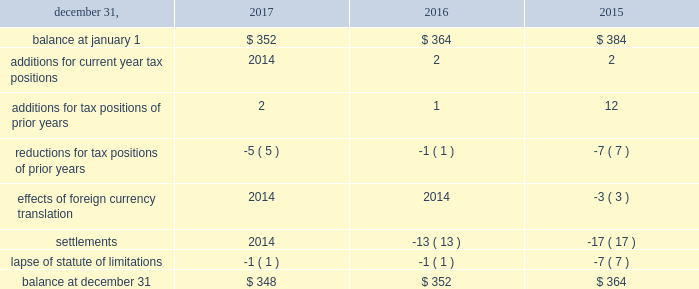The aes corporation notes to consolidated financial statements 2014 ( continued ) december 31 , 2017 , 2016 , and 2015 the total amount of unrecognized tax benefits anticipated to result in a net decrease to unrecognized tax benefits within 12 months of december 31 , 2017 is estimated to be between $ 5 million and $ 15 million , primarily relating to statute of limitation lapses and tax exam settlements .
The following is a reconciliation of the beginning and ending amounts of unrecognized tax benefits for the periods indicated ( in millions ) : .
The company and certain of its subsidiaries are currently under examination by the relevant taxing authorities for various tax years .
The company regularly assesses the potential outcome of these examinations in each of the taxing jurisdictions when determining the adequacy of the amount of unrecognized tax benefit recorded .
While it is often difficult to predict the final outcome or the timing of resolution of any particular uncertain tax position , we believe we have appropriately accrued for our uncertain tax benefits .
However , audit outcomes and the timing of audit settlements and future events that would impact our previously recorded unrecognized tax benefits and the range of anticipated increases or decreases in unrecognized tax benefits are subject to significant uncertainty .
It is possible that the ultimate outcome of current or future examinations may exceed our provision for current unrecognized tax benefits in amounts that could be material , but cannot be estimated as of december 31 , 2017 .
Our effective tax rate and net income in any given future period could therefore be materially impacted .
21 .
Discontinued operations due to a portfolio evaluation in the first half of 2016 , management decided to pursue a strategic shift of its distribution companies in brazil , sul and eletropaulo , to reduce the company's exposure to the brazilian distribution market .
Eletropaulo 2014 in november 2017 , eletropaulo converted its preferred shares into ordinary shares and transitioned the listing of those shares into the novo mercado , which is a listing segment of the brazilian stock exchange with the highest standards of corporate governance .
Upon conversion of the preferred shares into ordinary shares , aes no longer controlled eletropaulo , but maintained significant influence over the business .
As a result , the company deconsolidated eletropaulo .
After deconsolidation , the company's 17% ( 17 % ) ownership interest is reflected as an equity method investment .
The company recorded an after-tax loss on deconsolidation of $ 611 million , which primarily consisted of $ 455 million related to cumulative translation losses and $ 243 million related to pension losses reclassified from aocl .
In december 2017 , all the remaining criteria were met for eletropaulo to qualify as a discontinued operation .
Therefore , its results of operations and financial position were reported as such in the consolidated financial statements for all periods presented .
Eletropaulo's pre-tax loss attributable to aes , including the loss on deconsolidation , for the years ended december 31 , 2017 and 2016 was $ 633 million and $ 192 million , respectively .
Eletropaulo's pre-tax income attributable to aes for the year ended december 31 , 2015 was $ 73 million .
Prior to its classification as discontinued operations , eletropaulo was reported in the brazil sbu reportable segment .
Sul 2014 the company executed an agreement for the sale of sul , a wholly-owned subsidiary , in june 2016 .
The results of operations and financial position of sul are reported as discontinued operations in the consolidated financial statements for all periods presented .
Upon meeting the held-for-sale criteria , the company recognized an after-tax loss of $ 382 million comprised of a pre-tax impairment charge of $ 783 million , offset by a tax benefit of $ 266 million related to the impairment of the sul long lived assets and a tax benefit of $ 135 million for deferred taxes related to the investment in sul .
Prior to the impairment charge , the carrying value of the sul asset group of $ 1.6 billion was greater than its approximate fair value less costs to sell .
However , the impairment charge was limited to the carrying value of the long lived assets of the sul disposal group .
On october 31 , 2016 , the company completed the sale of sul and received final proceeds less costs to sell of $ 484 million , excluding contingent consideration .
Upon disposal of sul , the company incurred an additional after-tax .
What would the ending amount of unrecognized tax benefits for 2015 be ( in millions ) without settlements? 
Computations: (364 - -17)
Answer: 381.0. 